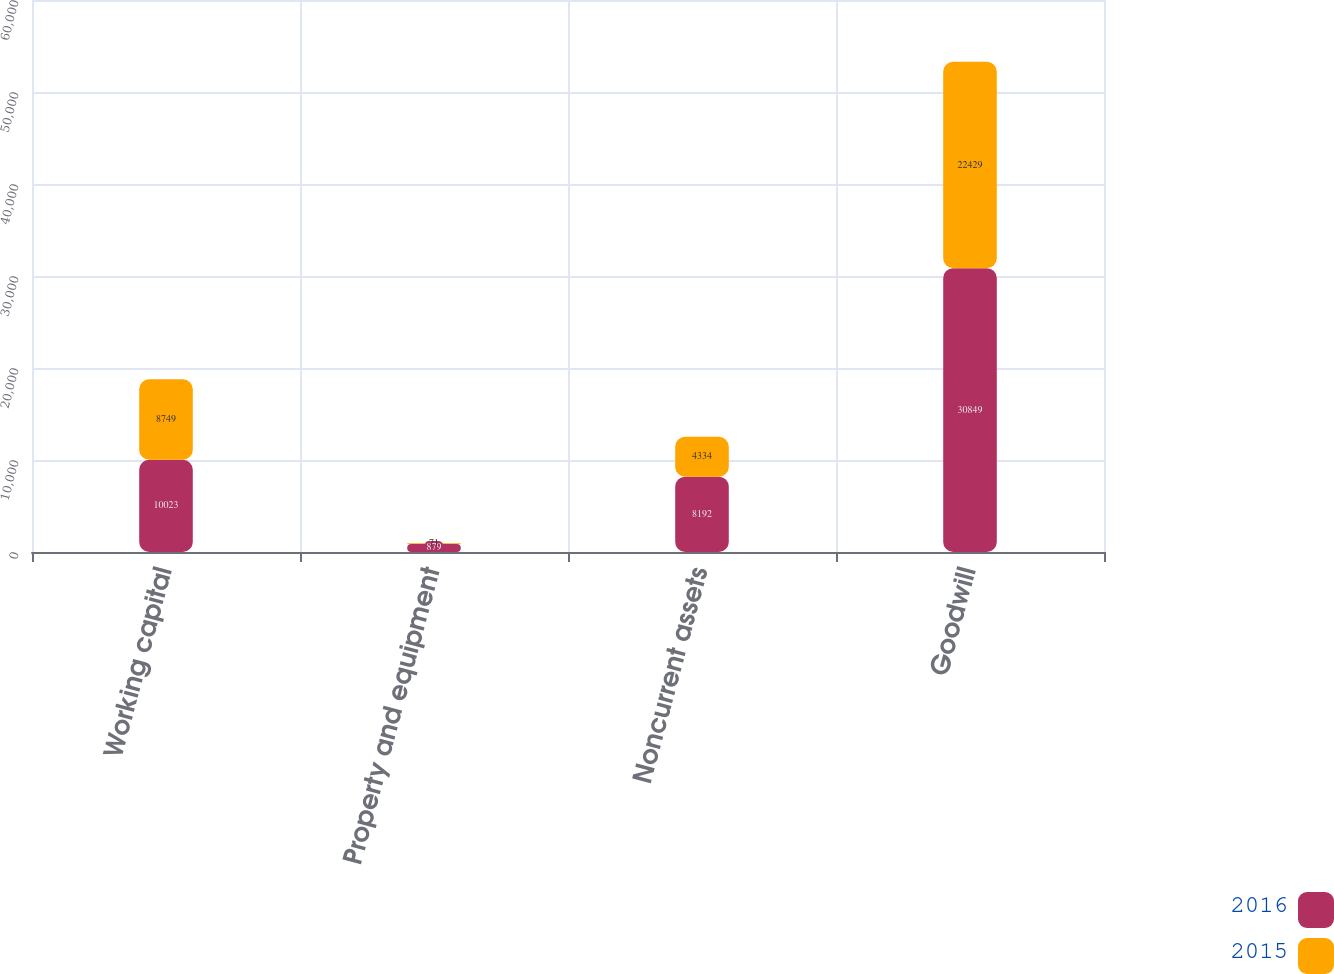<chart> <loc_0><loc_0><loc_500><loc_500><stacked_bar_chart><ecel><fcel>Working capital<fcel>Property and equipment<fcel>Noncurrent assets<fcel>Goodwill<nl><fcel>2016<fcel>10023<fcel>879<fcel>8192<fcel>30849<nl><fcel>2015<fcel>8749<fcel>71<fcel>4334<fcel>22429<nl></chart> 